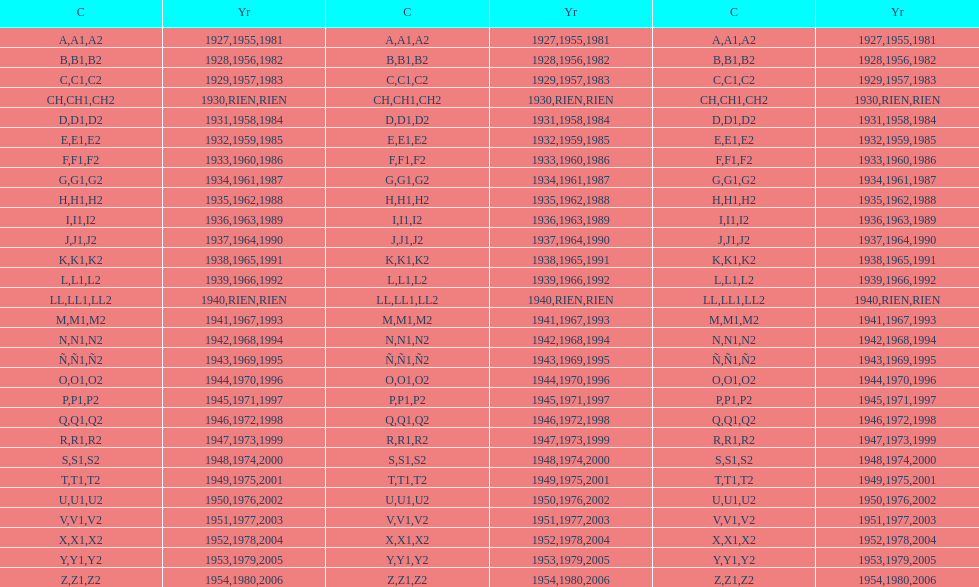What was the lowest year stamped? 1927. 